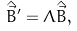<formula> <loc_0><loc_0><loc_500><loc_500>\hat { \vec { B } } ^ { \prime } = \Lambda \hat { \vec { B } } ,</formula> 